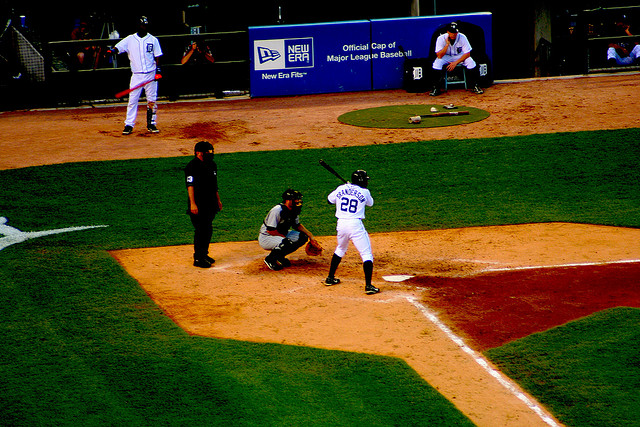Identify and read out the text in this image. 28 NEW ERA New official n Fits Era Baseball League Major 01 Cap 